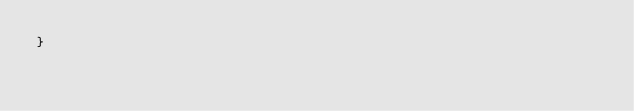Convert code to text. <code><loc_0><loc_0><loc_500><loc_500><_Java_>}
</code> 